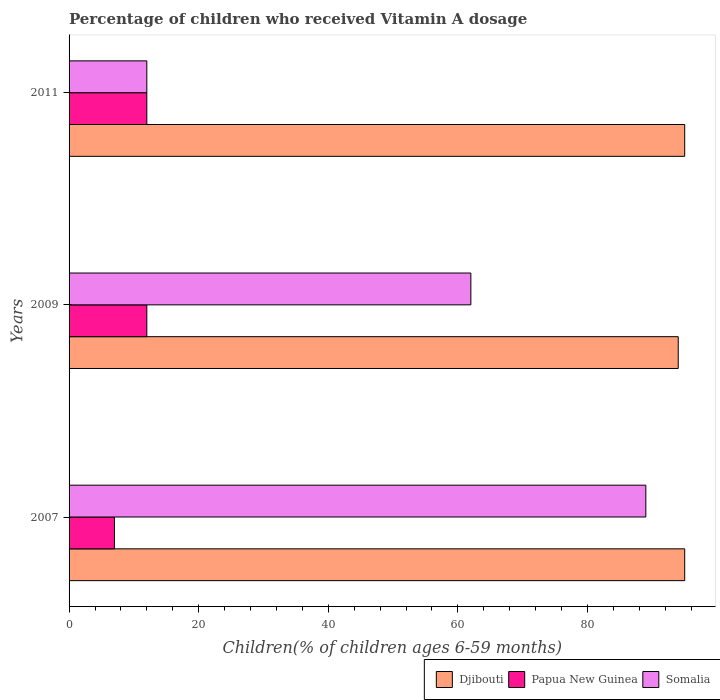How many different coloured bars are there?
Provide a short and direct response. 3. How many groups of bars are there?
Make the answer very short. 3. Are the number of bars on each tick of the Y-axis equal?
Offer a very short reply. Yes. What is the label of the 2nd group of bars from the top?
Provide a short and direct response. 2009. In how many cases, is the number of bars for a given year not equal to the number of legend labels?
Your answer should be compact. 0. What is the percentage of children who received Vitamin A dosage in Papua New Guinea in 2011?
Provide a short and direct response. 12. Across all years, what is the minimum percentage of children who received Vitamin A dosage in Somalia?
Offer a terse response. 12. In which year was the percentage of children who received Vitamin A dosage in Papua New Guinea maximum?
Your answer should be very brief. 2009. What is the total percentage of children who received Vitamin A dosage in Somalia in the graph?
Make the answer very short. 163. What is the difference between the percentage of children who received Vitamin A dosage in Papua New Guinea in 2009 and that in 2011?
Ensure brevity in your answer.  0. What is the difference between the percentage of children who received Vitamin A dosage in Somalia in 2009 and the percentage of children who received Vitamin A dosage in Djibouti in 2007?
Provide a short and direct response. -33. What is the average percentage of children who received Vitamin A dosage in Somalia per year?
Ensure brevity in your answer.  54.33. In the year 2009, what is the difference between the percentage of children who received Vitamin A dosage in Somalia and percentage of children who received Vitamin A dosage in Djibouti?
Your answer should be very brief. -32. What is the ratio of the percentage of children who received Vitamin A dosage in Papua New Guinea in 2009 to that in 2011?
Your answer should be very brief. 1. Is the percentage of children who received Vitamin A dosage in Djibouti in 2007 less than that in 2009?
Your answer should be very brief. No. Is the difference between the percentage of children who received Vitamin A dosage in Somalia in 2007 and 2009 greater than the difference between the percentage of children who received Vitamin A dosage in Djibouti in 2007 and 2009?
Offer a very short reply. Yes. In how many years, is the percentage of children who received Vitamin A dosage in Somalia greater than the average percentage of children who received Vitamin A dosage in Somalia taken over all years?
Give a very brief answer. 2. What does the 3rd bar from the top in 2011 represents?
Provide a short and direct response. Djibouti. What does the 3rd bar from the bottom in 2009 represents?
Offer a terse response. Somalia. How many bars are there?
Provide a short and direct response. 9. Are all the bars in the graph horizontal?
Your response must be concise. Yes. How many years are there in the graph?
Offer a very short reply. 3. What is the difference between two consecutive major ticks on the X-axis?
Offer a terse response. 20. Does the graph contain grids?
Your answer should be compact. No. Where does the legend appear in the graph?
Give a very brief answer. Bottom right. What is the title of the graph?
Offer a terse response. Percentage of children who received Vitamin A dosage. Does "Singapore" appear as one of the legend labels in the graph?
Provide a succinct answer. No. What is the label or title of the X-axis?
Provide a succinct answer. Children(% of children ages 6-59 months). What is the Children(% of children ages 6-59 months) of Papua New Guinea in 2007?
Give a very brief answer. 7. What is the Children(% of children ages 6-59 months) of Somalia in 2007?
Give a very brief answer. 89. What is the Children(% of children ages 6-59 months) in Djibouti in 2009?
Provide a succinct answer. 94. Across all years, what is the maximum Children(% of children ages 6-59 months) of Papua New Guinea?
Offer a terse response. 12. Across all years, what is the maximum Children(% of children ages 6-59 months) in Somalia?
Provide a short and direct response. 89. Across all years, what is the minimum Children(% of children ages 6-59 months) in Djibouti?
Keep it short and to the point. 94. Across all years, what is the minimum Children(% of children ages 6-59 months) in Papua New Guinea?
Make the answer very short. 7. Across all years, what is the minimum Children(% of children ages 6-59 months) of Somalia?
Your response must be concise. 12. What is the total Children(% of children ages 6-59 months) of Djibouti in the graph?
Offer a very short reply. 284. What is the total Children(% of children ages 6-59 months) in Papua New Guinea in the graph?
Provide a short and direct response. 31. What is the total Children(% of children ages 6-59 months) in Somalia in the graph?
Your response must be concise. 163. What is the difference between the Children(% of children ages 6-59 months) of Papua New Guinea in 2007 and that in 2009?
Keep it short and to the point. -5. What is the difference between the Children(% of children ages 6-59 months) of Djibouti in 2009 and that in 2011?
Your answer should be very brief. -1. What is the difference between the Children(% of children ages 6-59 months) of Djibouti in 2007 and the Children(% of children ages 6-59 months) of Papua New Guinea in 2009?
Provide a succinct answer. 83. What is the difference between the Children(% of children ages 6-59 months) of Djibouti in 2007 and the Children(% of children ages 6-59 months) of Somalia in 2009?
Give a very brief answer. 33. What is the difference between the Children(% of children ages 6-59 months) of Papua New Guinea in 2007 and the Children(% of children ages 6-59 months) of Somalia in 2009?
Offer a very short reply. -55. What is the difference between the Children(% of children ages 6-59 months) of Djibouti in 2007 and the Children(% of children ages 6-59 months) of Somalia in 2011?
Ensure brevity in your answer.  83. What is the difference between the Children(% of children ages 6-59 months) of Djibouti in 2009 and the Children(% of children ages 6-59 months) of Papua New Guinea in 2011?
Give a very brief answer. 82. What is the difference between the Children(% of children ages 6-59 months) of Papua New Guinea in 2009 and the Children(% of children ages 6-59 months) of Somalia in 2011?
Offer a very short reply. 0. What is the average Children(% of children ages 6-59 months) of Djibouti per year?
Your response must be concise. 94.67. What is the average Children(% of children ages 6-59 months) of Papua New Guinea per year?
Offer a very short reply. 10.33. What is the average Children(% of children ages 6-59 months) in Somalia per year?
Offer a terse response. 54.33. In the year 2007, what is the difference between the Children(% of children ages 6-59 months) of Djibouti and Children(% of children ages 6-59 months) of Papua New Guinea?
Your answer should be compact. 88. In the year 2007, what is the difference between the Children(% of children ages 6-59 months) in Papua New Guinea and Children(% of children ages 6-59 months) in Somalia?
Your response must be concise. -82. In the year 2009, what is the difference between the Children(% of children ages 6-59 months) in Papua New Guinea and Children(% of children ages 6-59 months) in Somalia?
Offer a very short reply. -50. In the year 2011, what is the difference between the Children(% of children ages 6-59 months) of Djibouti and Children(% of children ages 6-59 months) of Somalia?
Make the answer very short. 83. In the year 2011, what is the difference between the Children(% of children ages 6-59 months) of Papua New Guinea and Children(% of children ages 6-59 months) of Somalia?
Provide a succinct answer. 0. What is the ratio of the Children(% of children ages 6-59 months) of Djibouti in 2007 to that in 2009?
Your response must be concise. 1.01. What is the ratio of the Children(% of children ages 6-59 months) of Papua New Guinea in 2007 to that in 2009?
Ensure brevity in your answer.  0.58. What is the ratio of the Children(% of children ages 6-59 months) in Somalia in 2007 to that in 2009?
Offer a terse response. 1.44. What is the ratio of the Children(% of children ages 6-59 months) in Papua New Guinea in 2007 to that in 2011?
Make the answer very short. 0.58. What is the ratio of the Children(% of children ages 6-59 months) of Somalia in 2007 to that in 2011?
Keep it short and to the point. 7.42. What is the ratio of the Children(% of children ages 6-59 months) of Papua New Guinea in 2009 to that in 2011?
Ensure brevity in your answer.  1. What is the ratio of the Children(% of children ages 6-59 months) of Somalia in 2009 to that in 2011?
Ensure brevity in your answer.  5.17. What is the difference between the highest and the second highest Children(% of children ages 6-59 months) of Papua New Guinea?
Provide a succinct answer. 0. What is the difference between the highest and the lowest Children(% of children ages 6-59 months) of Djibouti?
Offer a terse response. 1. What is the difference between the highest and the lowest Children(% of children ages 6-59 months) in Somalia?
Give a very brief answer. 77. 